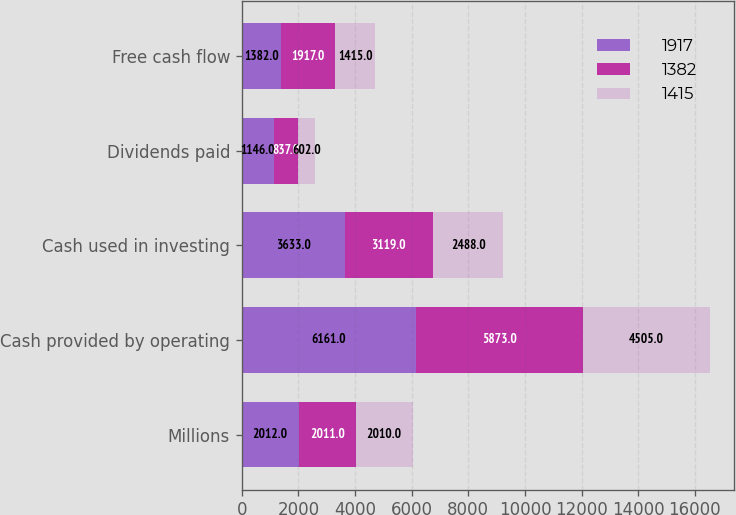Convert chart. <chart><loc_0><loc_0><loc_500><loc_500><stacked_bar_chart><ecel><fcel>Millions<fcel>Cash provided by operating<fcel>Cash used in investing<fcel>Dividends paid<fcel>Free cash flow<nl><fcel>1917<fcel>2012<fcel>6161<fcel>3633<fcel>1146<fcel>1382<nl><fcel>1382<fcel>2011<fcel>5873<fcel>3119<fcel>837<fcel>1917<nl><fcel>1415<fcel>2010<fcel>4505<fcel>2488<fcel>602<fcel>1415<nl></chart> 